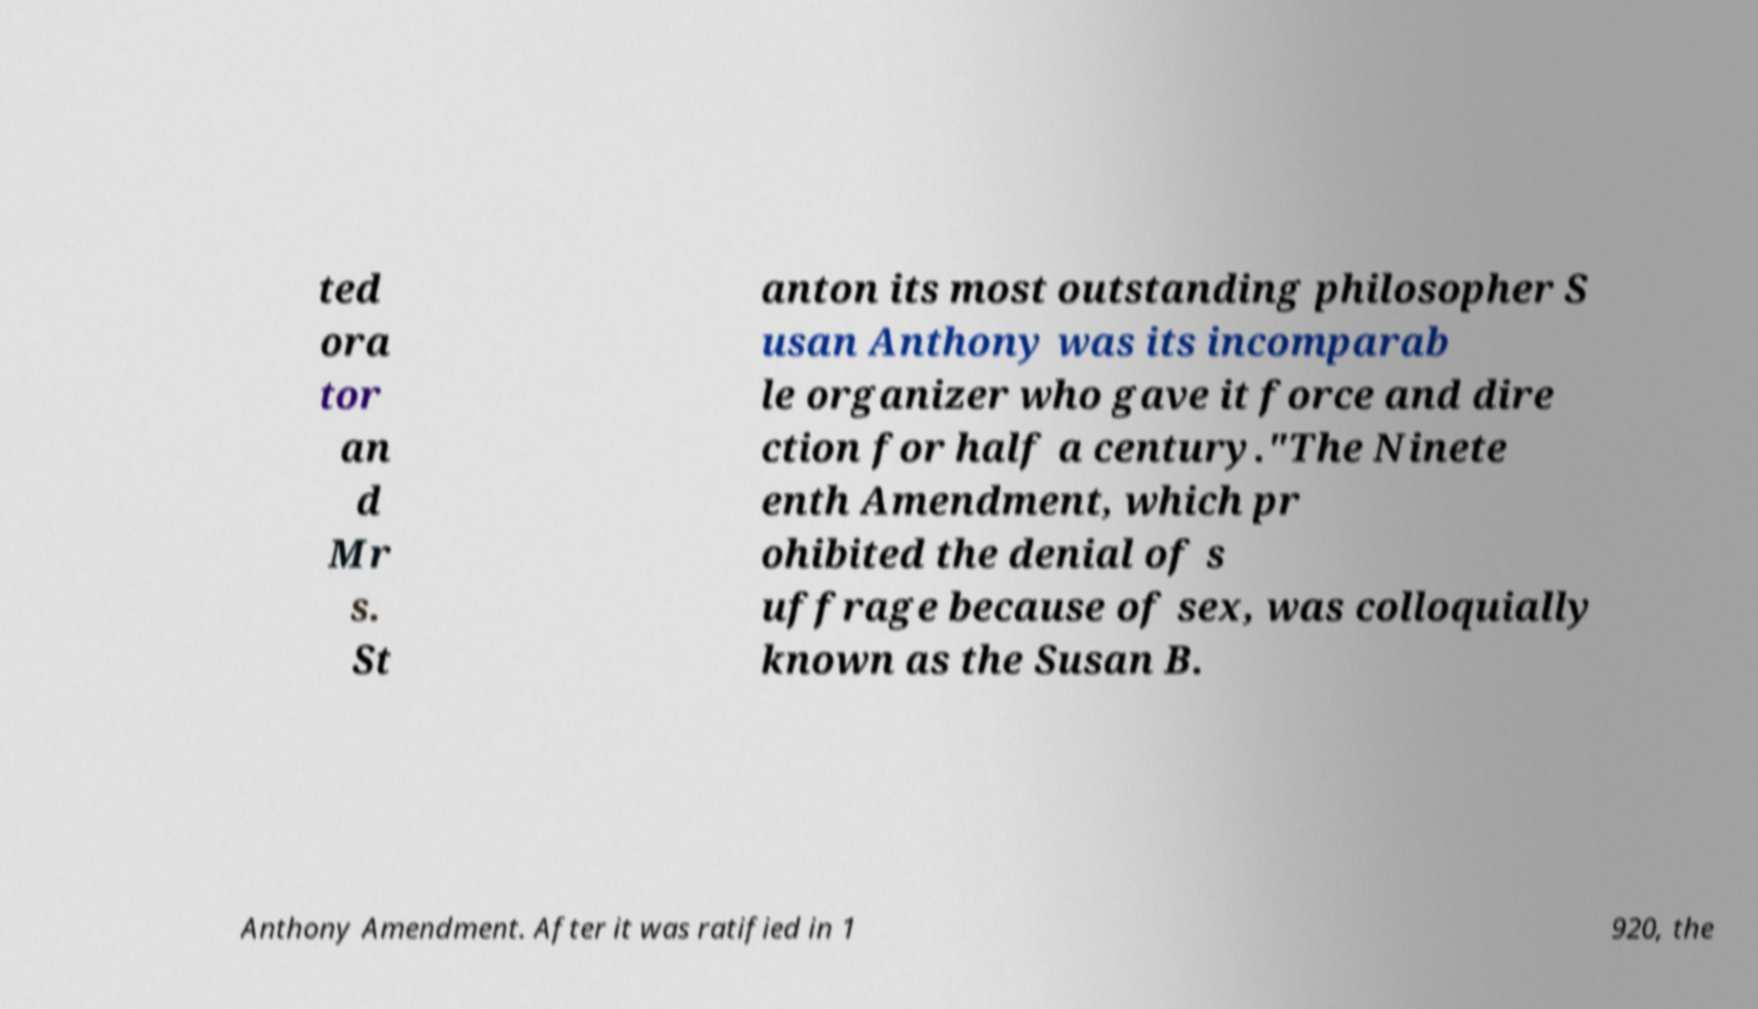Could you assist in decoding the text presented in this image and type it out clearly? ted ora tor an d Mr s. St anton its most outstanding philosopher S usan Anthony was its incomparab le organizer who gave it force and dire ction for half a century."The Ninete enth Amendment, which pr ohibited the denial of s uffrage because of sex, was colloquially known as the Susan B. Anthony Amendment. After it was ratified in 1 920, the 